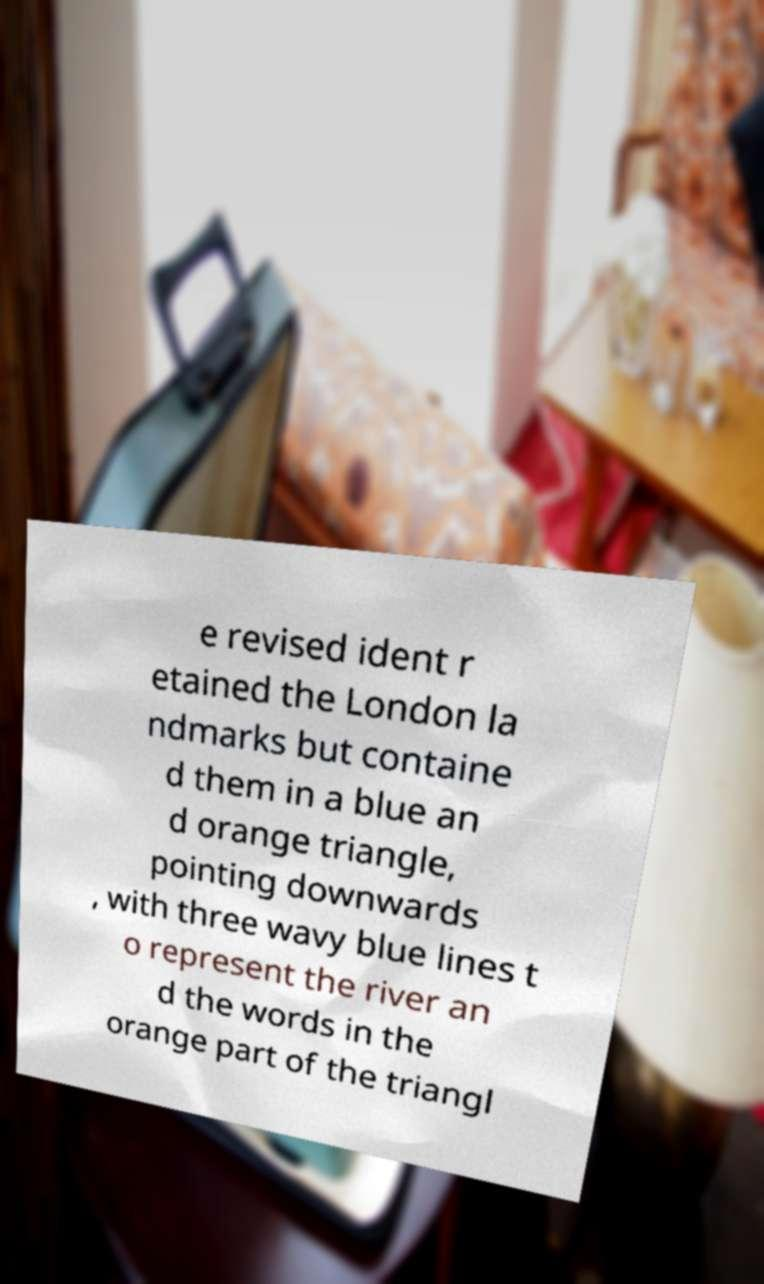Could you assist in decoding the text presented in this image and type it out clearly? e revised ident r etained the London la ndmarks but containe d them in a blue an d orange triangle, pointing downwards , with three wavy blue lines t o represent the river an d the words in the orange part of the triangl 